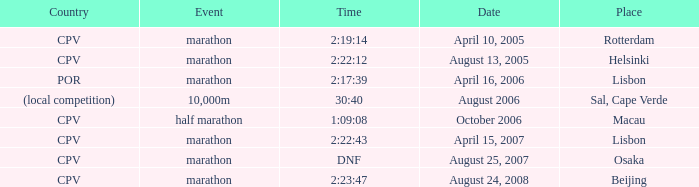Could you parse the entire table as a dict? {'header': ['Country', 'Event', 'Time', 'Date', 'Place'], 'rows': [['CPV', 'marathon', '2:19:14', 'April 10, 2005', 'Rotterdam'], ['CPV', 'marathon', '2:22:12', 'August 13, 2005', 'Helsinki'], ['POR', 'marathon', '2:17:39', 'April 16, 2006', 'Lisbon'], ['(local competition)', '10,000m', '30:40', 'August 2006', 'Sal, Cape Verde'], ['CPV', 'half marathon', '1:09:08', 'October 2006', 'Macau'], ['CPV', 'marathon', '2:22:43', 'April 15, 2007', 'Lisbon'], ['CPV', 'marathon', 'DNF', 'August 25, 2007', 'Osaka'], ['CPV', 'marathon', '2:23:47', 'August 24, 2008', 'Beijing']]} What's the meaning of the event titled country of (local competition)? 10,000m. 